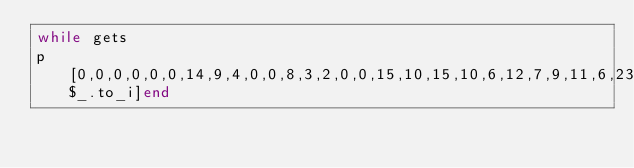<code> <loc_0><loc_0><loc_500><loc_500><_Ruby_>while gets
p [0,0,0,0,0,0,14,9,4,0,0,8,3,2,0,0,15,10,15,10,6,12,7,9,11,6,23,18,13,8,3,23,18,13,8,3,34,29,24,22,17,28,23,24,19,27,34,29,35,30,28,31,28,23,24,28,42,37,32,27,22,42,37,32,27,22,53,48,43,41,36,47,42,43,38,46,64,59,54,49,44,61,56,51,46,44,72,67,62,57,52,72,67,62,57,52,83,78,73,71][$_.to_i]end</code> 